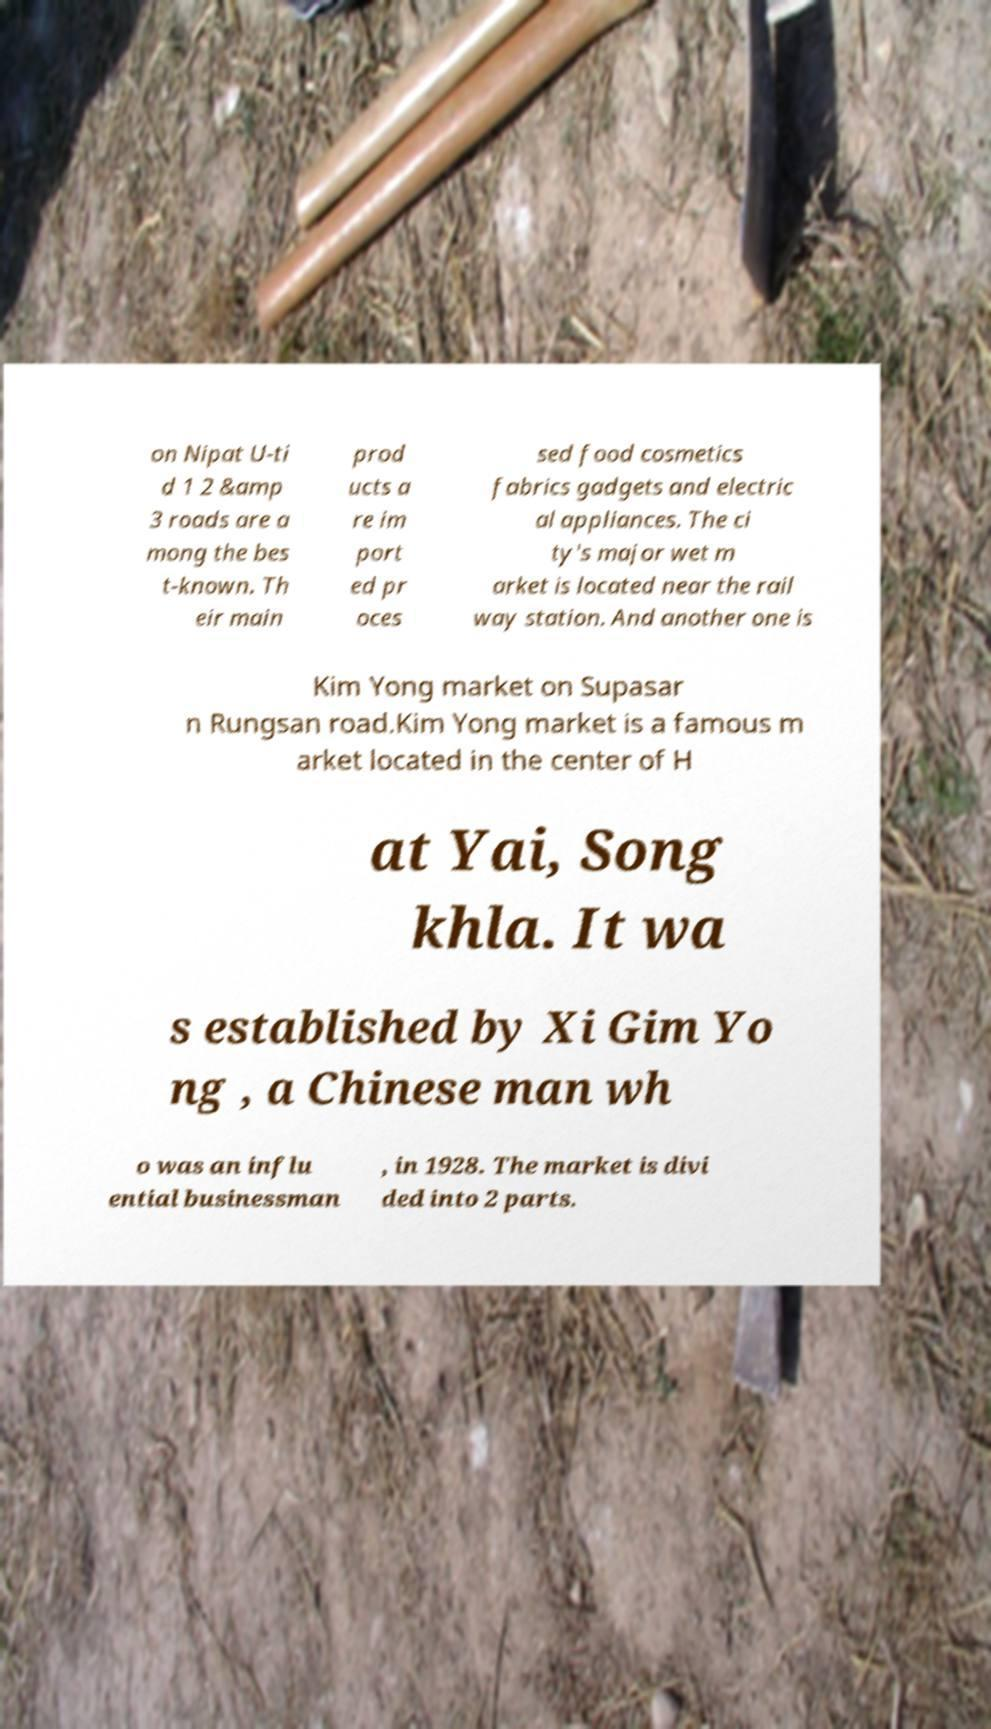Can you read and provide the text displayed in the image?This photo seems to have some interesting text. Can you extract and type it out for me? on Nipat U-ti d 1 2 &amp 3 roads are a mong the bes t-known. Th eir main prod ucts a re im port ed pr oces sed food cosmetics fabrics gadgets and electric al appliances. The ci ty's major wet m arket is located near the rail way station. And another one is Kim Yong market on Supasar n Rungsan road.Kim Yong market is a famous m arket located in the center of H at Yai, Song khla. It wa s established by Xi Gim Yo ng , a Chinese man wh o was an influ ential businessman , in 1928. The market is divi ded into 2 parts. 